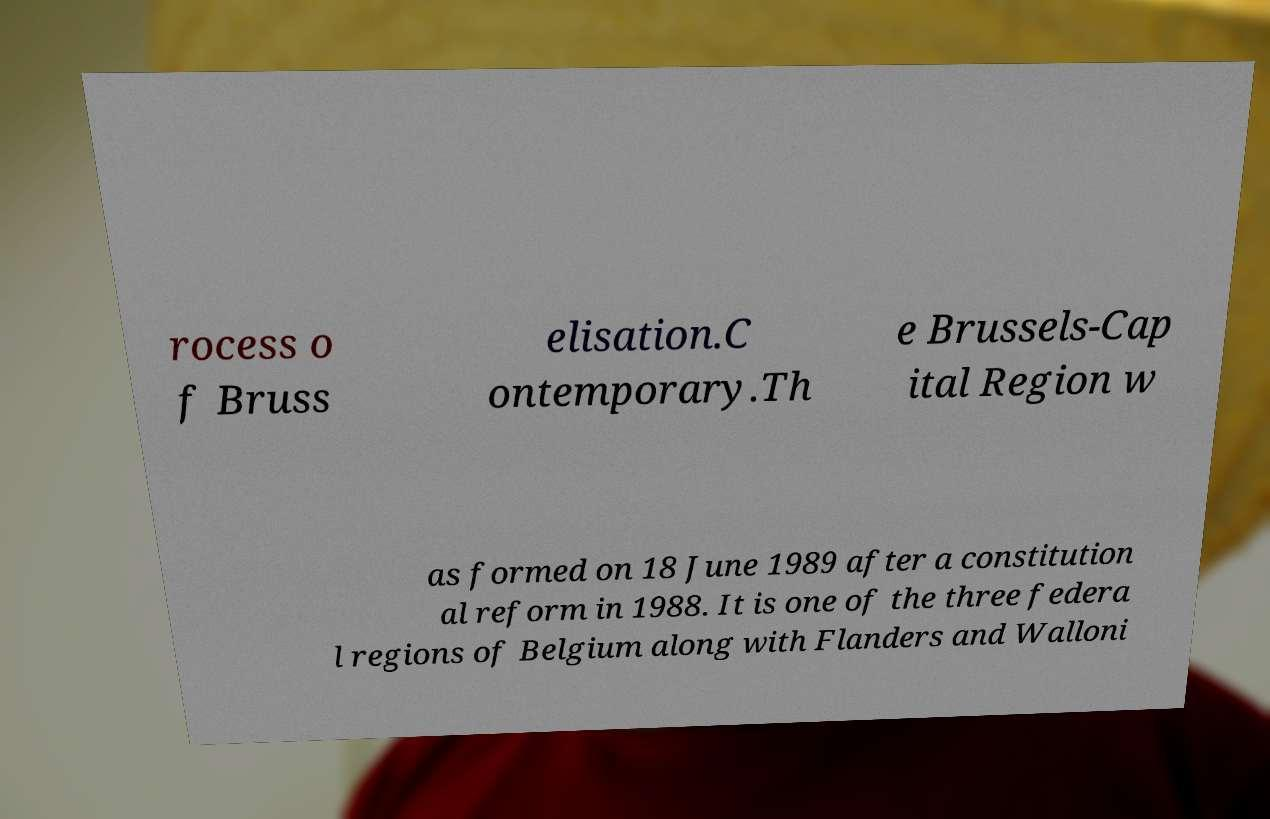Please identify and transcribe the text found in this image. rocess o f Bruss elisation.C ontemporary.Th e Brussels-Cap ital Region w as formed on 18 June 1989 after a constitution al reform in 1988. It is one of the three federa l regions of Belgium along with Flanders and Walloni 